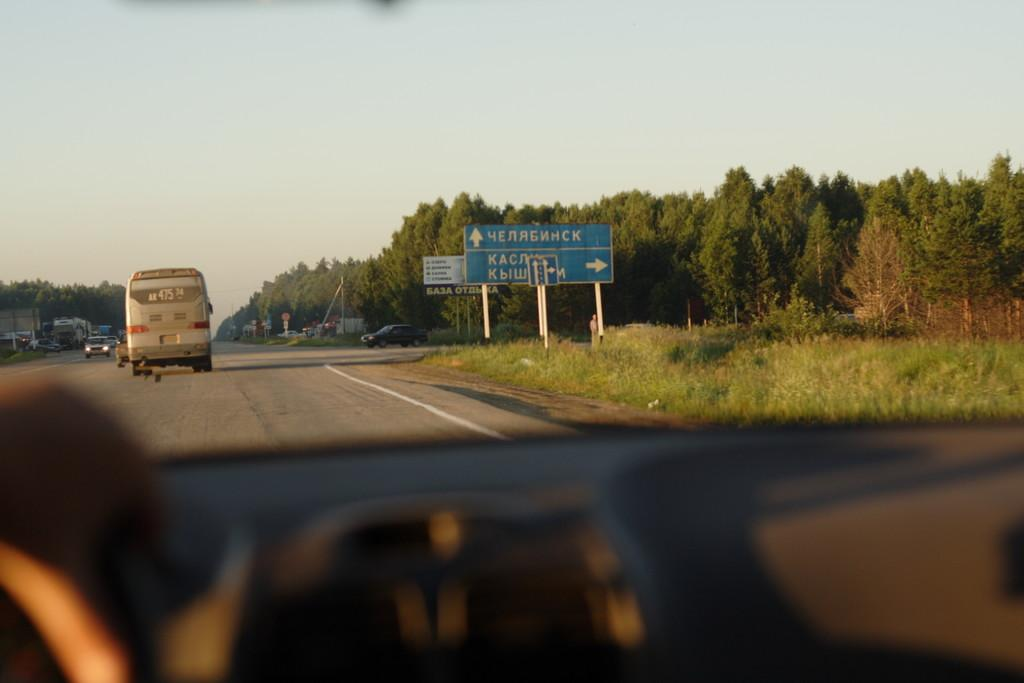What can be seen on the road in the image? There are vehicles on the road in the image. What type of vegetation is present at the side of the road? There are trees at the side of the road. What structures can be seen at the side of the road? There are signboards and poles at the side of the road. What type of ground cover is present at the side of the road? There is grass at the side of the road. What part of the natural environment is visible in the image? The sky is visible in the image. How many buttons are on the credit card in the image? There is no credit card or button present in the image. How many sisters are visible in the image? There are no people, let alone sisters, visible in the image. 